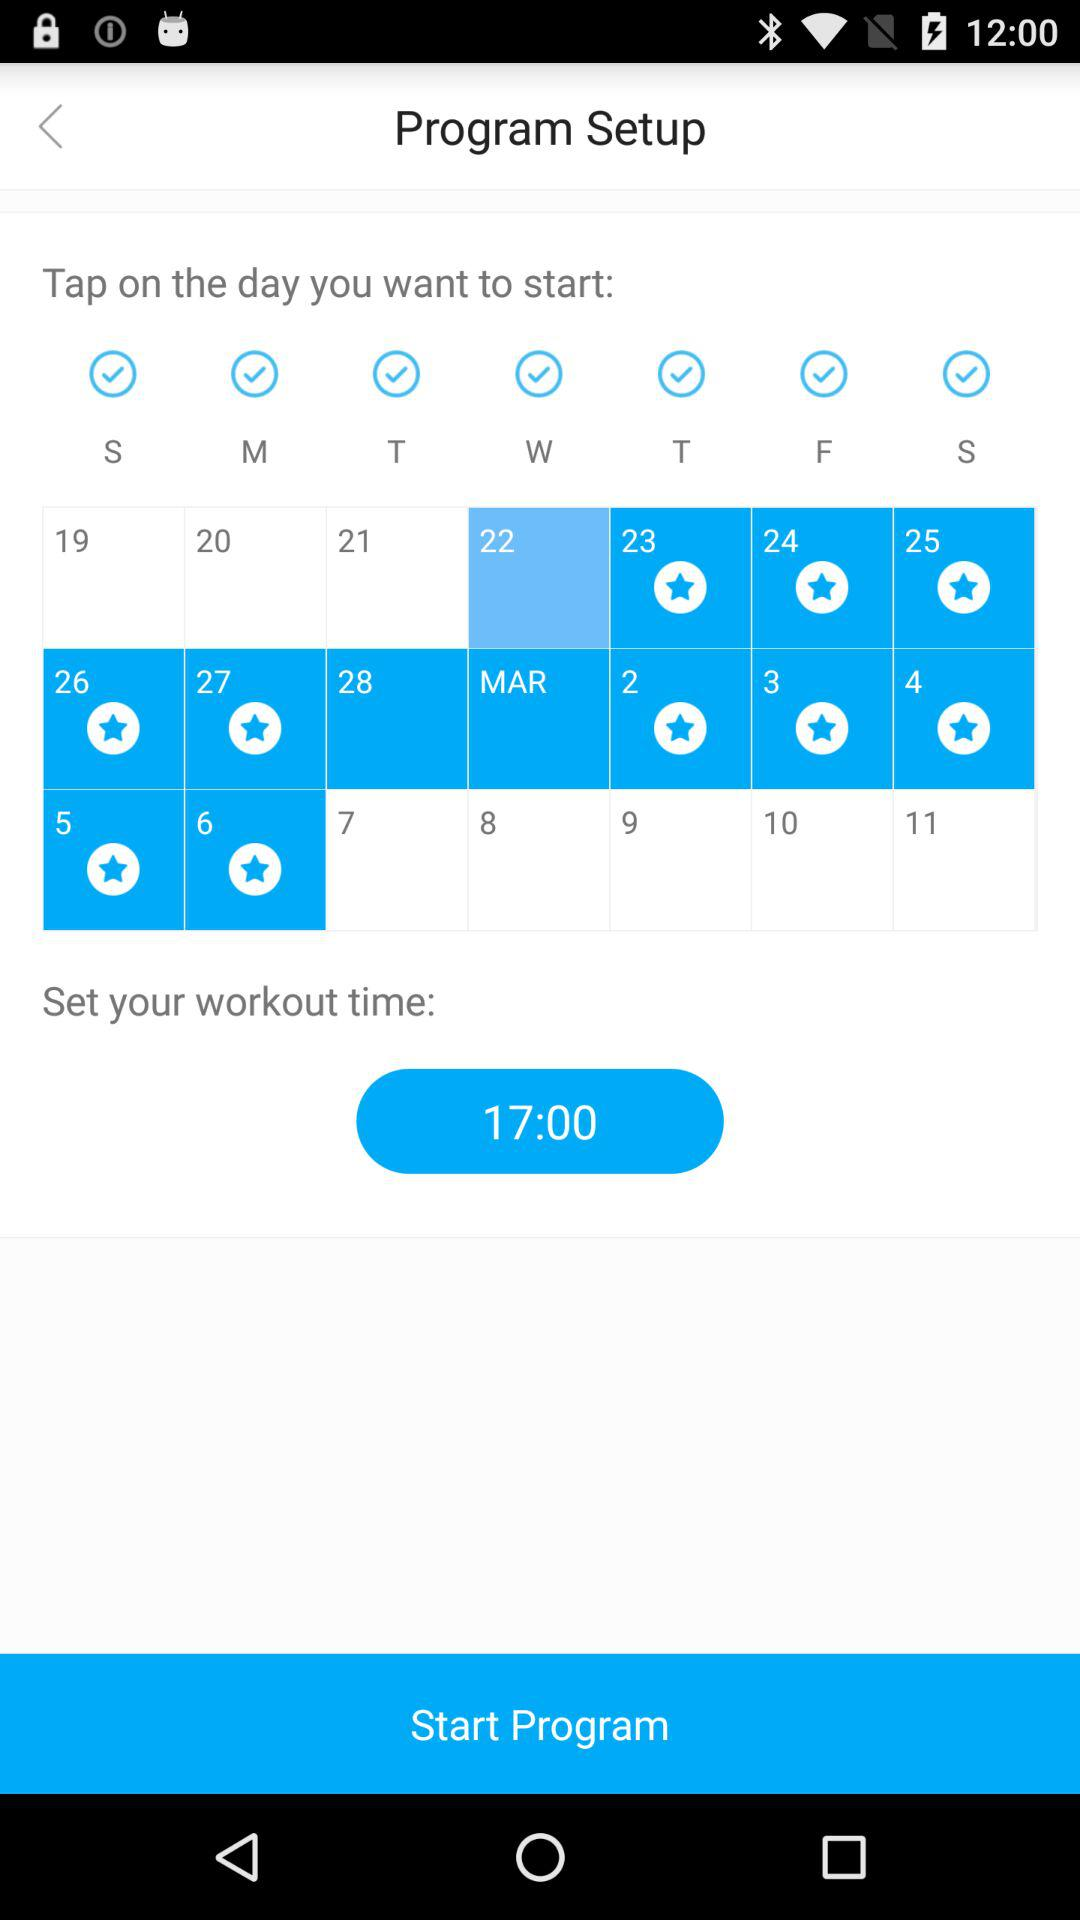Which exercises are selected for the workout?
When the provided information is insufficient, respond with <no answer>. <no answer> 